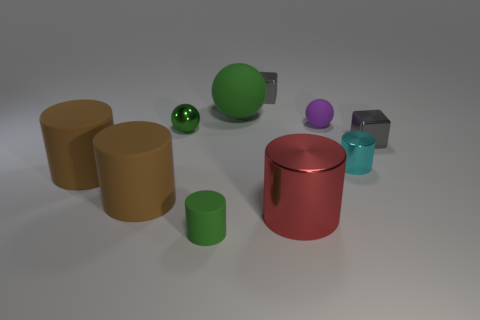What number of other things are there of the same shape as the large red thing?
Offer a very short reply. 4. How many tiny gray cubes are to the right of the small purple rubber ball?
Provide a succinct answer. 1. How big is the sphere that is on the right side of the tiny shiny sphere and to the left of the tiny purple sphere?
Your answer should be compact. Large. Are any big purple matte blocks visible?
Offer a very short reply. No. How many other objects are the same size as the cyan thing?
Your response must be concise. 5. There is a small sphere on the left side of the big metallic cylinder; is its color the same as the small rubber object that is left of the big rubber ball?
Provide a short and direct response. Yes. There is a green matte thing that is the same shape as the green metallic object; what is its size?
Your answer should be very brief. Large. Is the green ball left of the big matte sphere made of the same material as the sphere to the right of the red metal cylinder?
Your answer should be compact. No. What number of shiny things are either small green things or small gray objects?
Your response must be concise. 3. There is a tiny block that is right of the large metal cylinder that is in front of the tiny cylinder right of the small green rubber object; what is it made of?
Keep it short and to the point. Metal. 